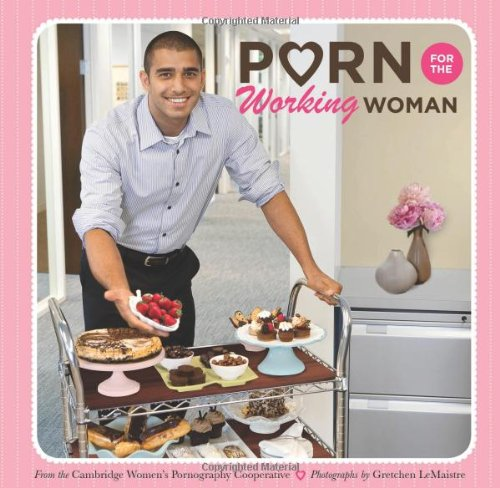Is this a comedy book? Yes, it is indeed a comedy book. Its content and thematic elements use humor to engage and entertain the reader, focusing on fun and playful depictions of various situations. 